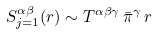<formula> <loc_0><loc_0><loc_500><loc_500>S _ { j = 1 } ^ { \alpha \beta } ( { r } ) \sim T ^ { \alpha \beta \gamma } \, \bar { \pi } ^ { \gamma } \, r \,</formula> 